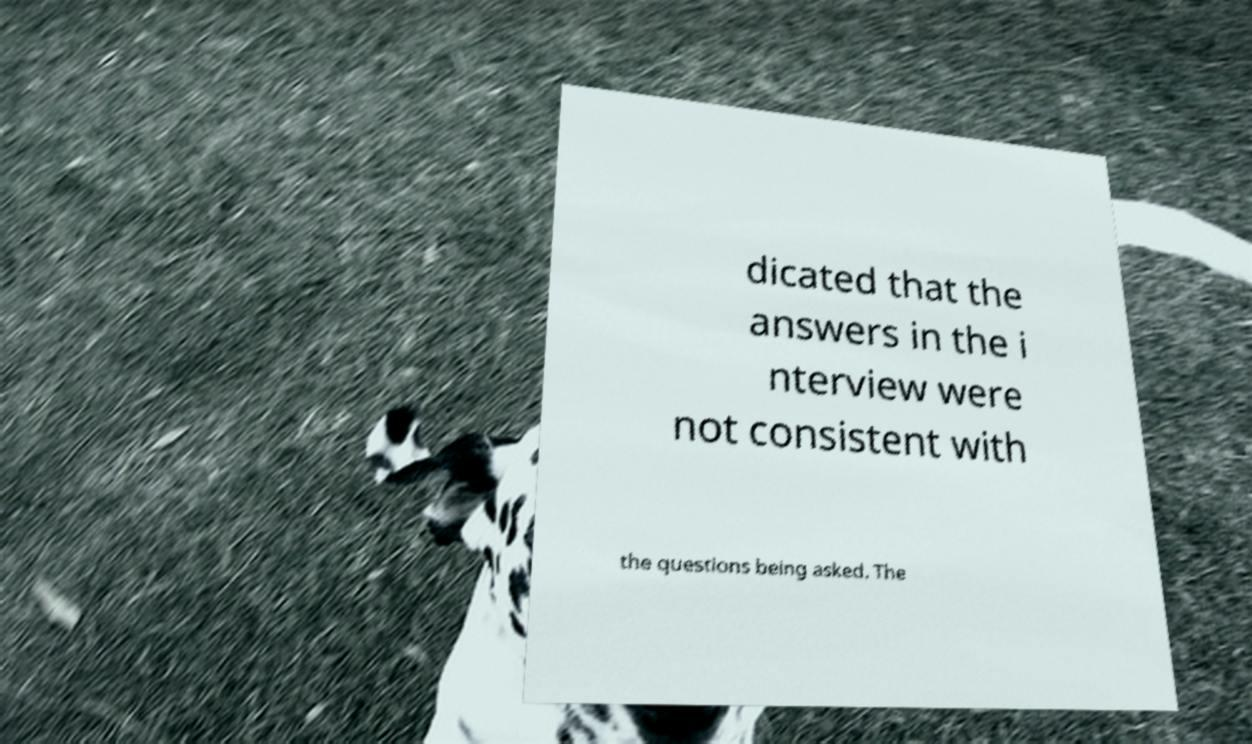Can you read and provide the text displayed in the image?This photo seems to have some interesting text. Can you extract and type it out for me? dicated that the answers in the i nterview were not consistent with the questions being asked. The 